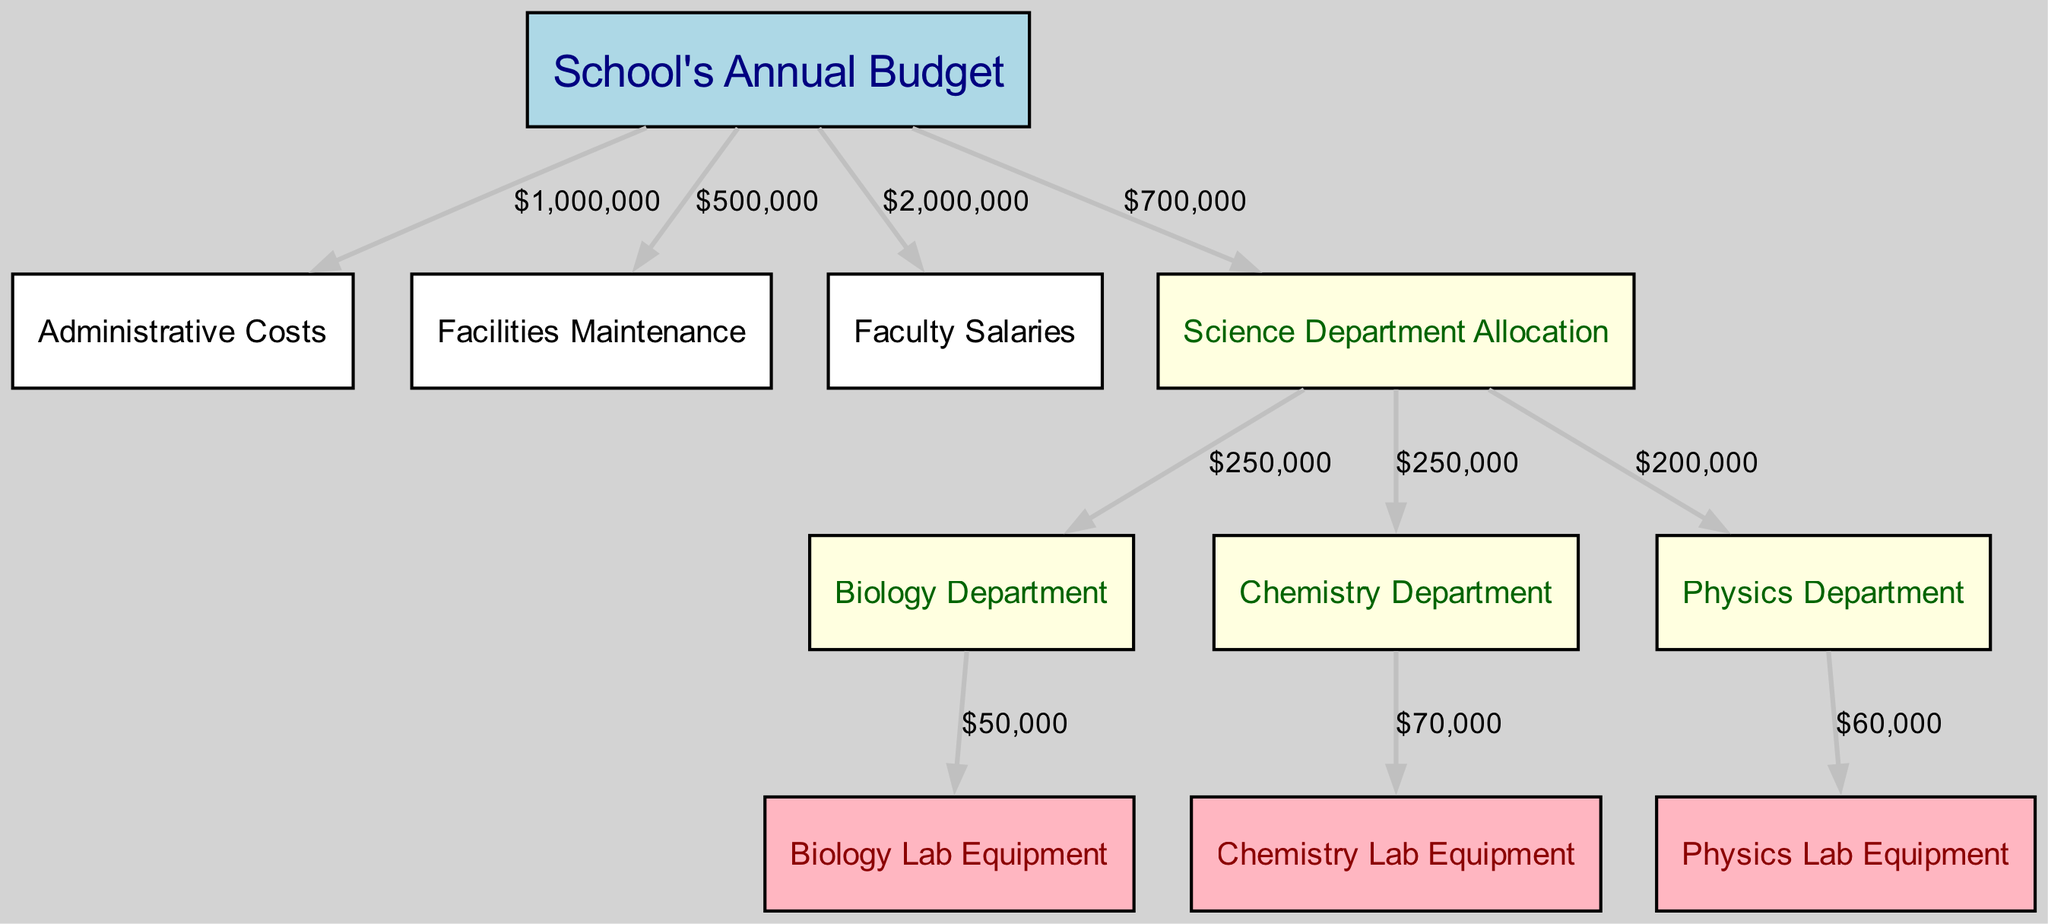What is the total allocation for the science department? The diagram indicates that the science department has an allocation of $700,000 directly from the school's annual budget.
Answer: $700,000 How much is allocated for biology lab equipment? The flow from the biology department to biology lab equipment shows an allocation of $50,000.
Answer: $50,000 Which department has the highest allocation for lab equipment? By comparing the allocations for lab equipment, the chemistry department has the highest allocation of $70,000.
Answer: Chemistry Department How much of the school's budget is spent on faculty salaries? The school budget allocates $2,000,000 for faculty salaries as shown in the diagram.
Answer: $2,000,000 What percentage of the science department's budget goes to the physics department? The physics department receives $200,000 out of the $700,000 allocated to the science department, which is approximately 28.57% when calculated.
Answer: 28.57% What is the total amount allocated for all types of lab equipment combined? By summing the allocations for biology, chemistry, and physics lab equipment ($50,000 + $70,000 + $60,000), the total is $180,000.
Answer: $180,000 Which node receives the least amount of funding from the science department? The biology department receives the least allocation of $250,000 compared to the chemistry and physics departments.
Answer: Biology Department What is the flow value from the school's budget to facilities maintenance? The flow shows that $500,000 is allocated from the school's budget to facilities maintenance.
Answer: $500,000 How many edges are present in the allocation diagram? The diagram contains a total of 10 edges, illustrating the various flows from one node to another.
Answer: 10 